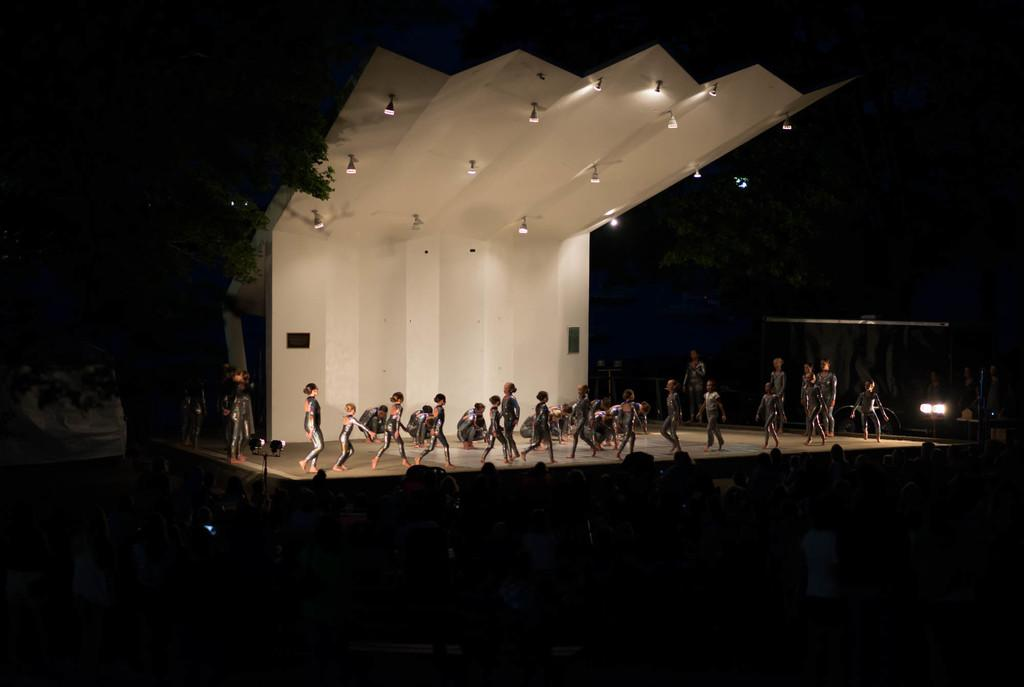What is happening on the stage in the image? There are people on the stage in the image. Can you describe the audience in the image? There are people in front of the stage in the image. What can be seen on the right side of the image? There is light on the right side of the image. What is the condition of the background in the image? The background of the image is completely dark. What type of pump is visible in the image? There is no pump present in the image. How does the toothpaste affect the people on the stage in the image? There is no toothpaste present in the image, so it cannot affect the people on the stage. 